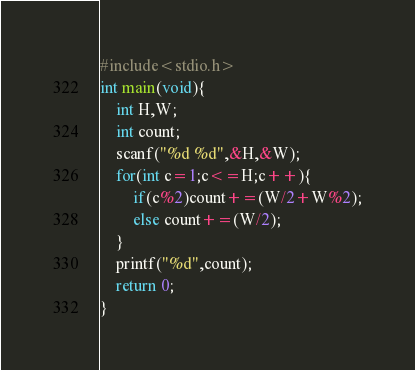<code> <loc_0><loc_0><loc_500><loc_500><_C_>#include<stdio.h>
int main(void){
	int H,W;
  	int count;
  	scanf("%d %d",&H,&W);
  	for(int c=1;c<=H;c++){
    	if(c%2)count+=(W/2+W%2);
    	else count+=(W/2);
  	}
  	printf("%d",count);
  	return 0;
}</code> 